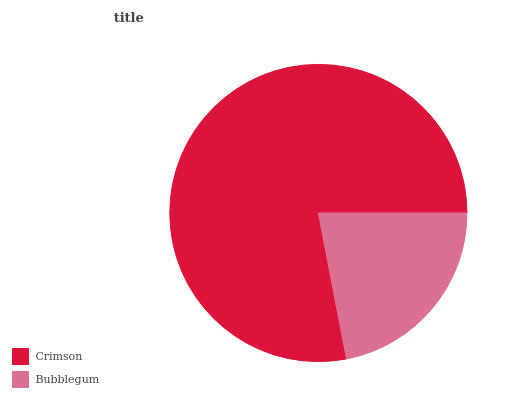Is Bubblegum the minimum?
Answer yes or no. Yes. Is Crimson the maximum?
Answer yes or no. Yes. Is Bubblegum the maximum?
Answer yes or no. No. Is Crimson greater than Bubblegum?
Answer yes or no. Yes. Is Bubblegum less than Crimson?
Answer yes or no. Yes. Is Bubblegum greater than Crimson?
Answer yes or no. No. Is Crimson less than Bubblegum?
Answer yes or no. No. Is Crimson the high median?
Answer yes or no. Yes. Is Bubblegum the low median?
Answer yes or no. Yes. Is Bubblegum the high median?
Answer yes or no. No. Is Crimson the low median?
Answer yes or no. No. 